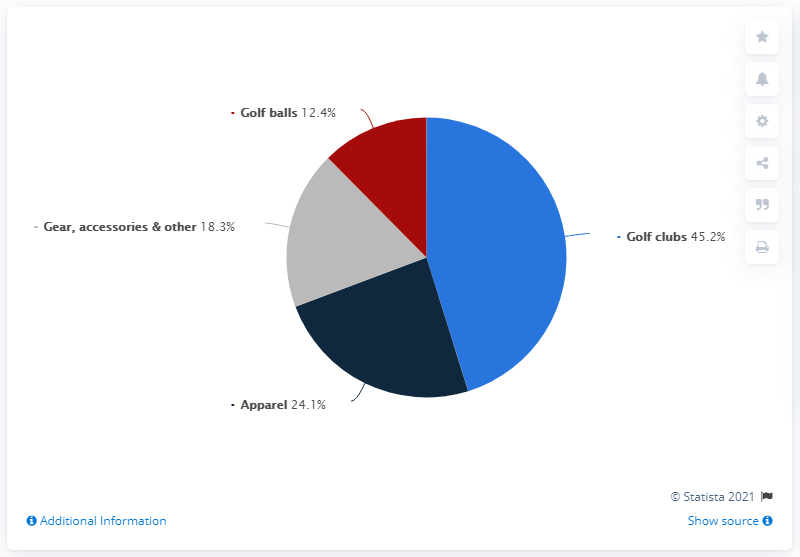Outline some significant characteristics in this image. The sum of sales from golf balls, gear and accessories, and apparel is greater than that of golf clubs. The segment that is less than 1/3 of the light blue segment is the red segment. In 2019, Callaway Golf reported that golf clubs accounted for 45.2% of its total sales. 